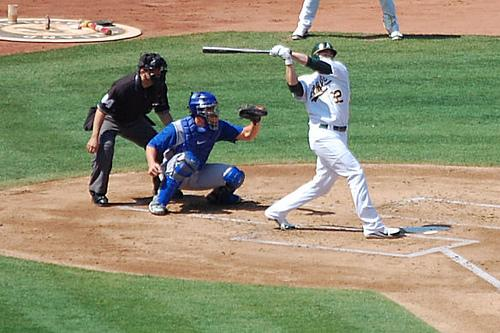What call will the umpire most likely make? Please explain your reasoning. strike. The ball catcher guy has his mitt in a closed fashion as if he caught the ball. 